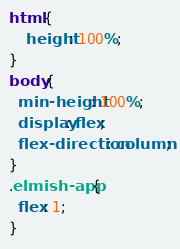<code> <loc_0><loc_0><loc_500><loc_500><_CSS_>html {
    height: 100%;
}
body {
  min-height: 100%;
  display: flex;
  flex-direction: column;
}
.elmish-app {
  flex: 1;
}</code> 